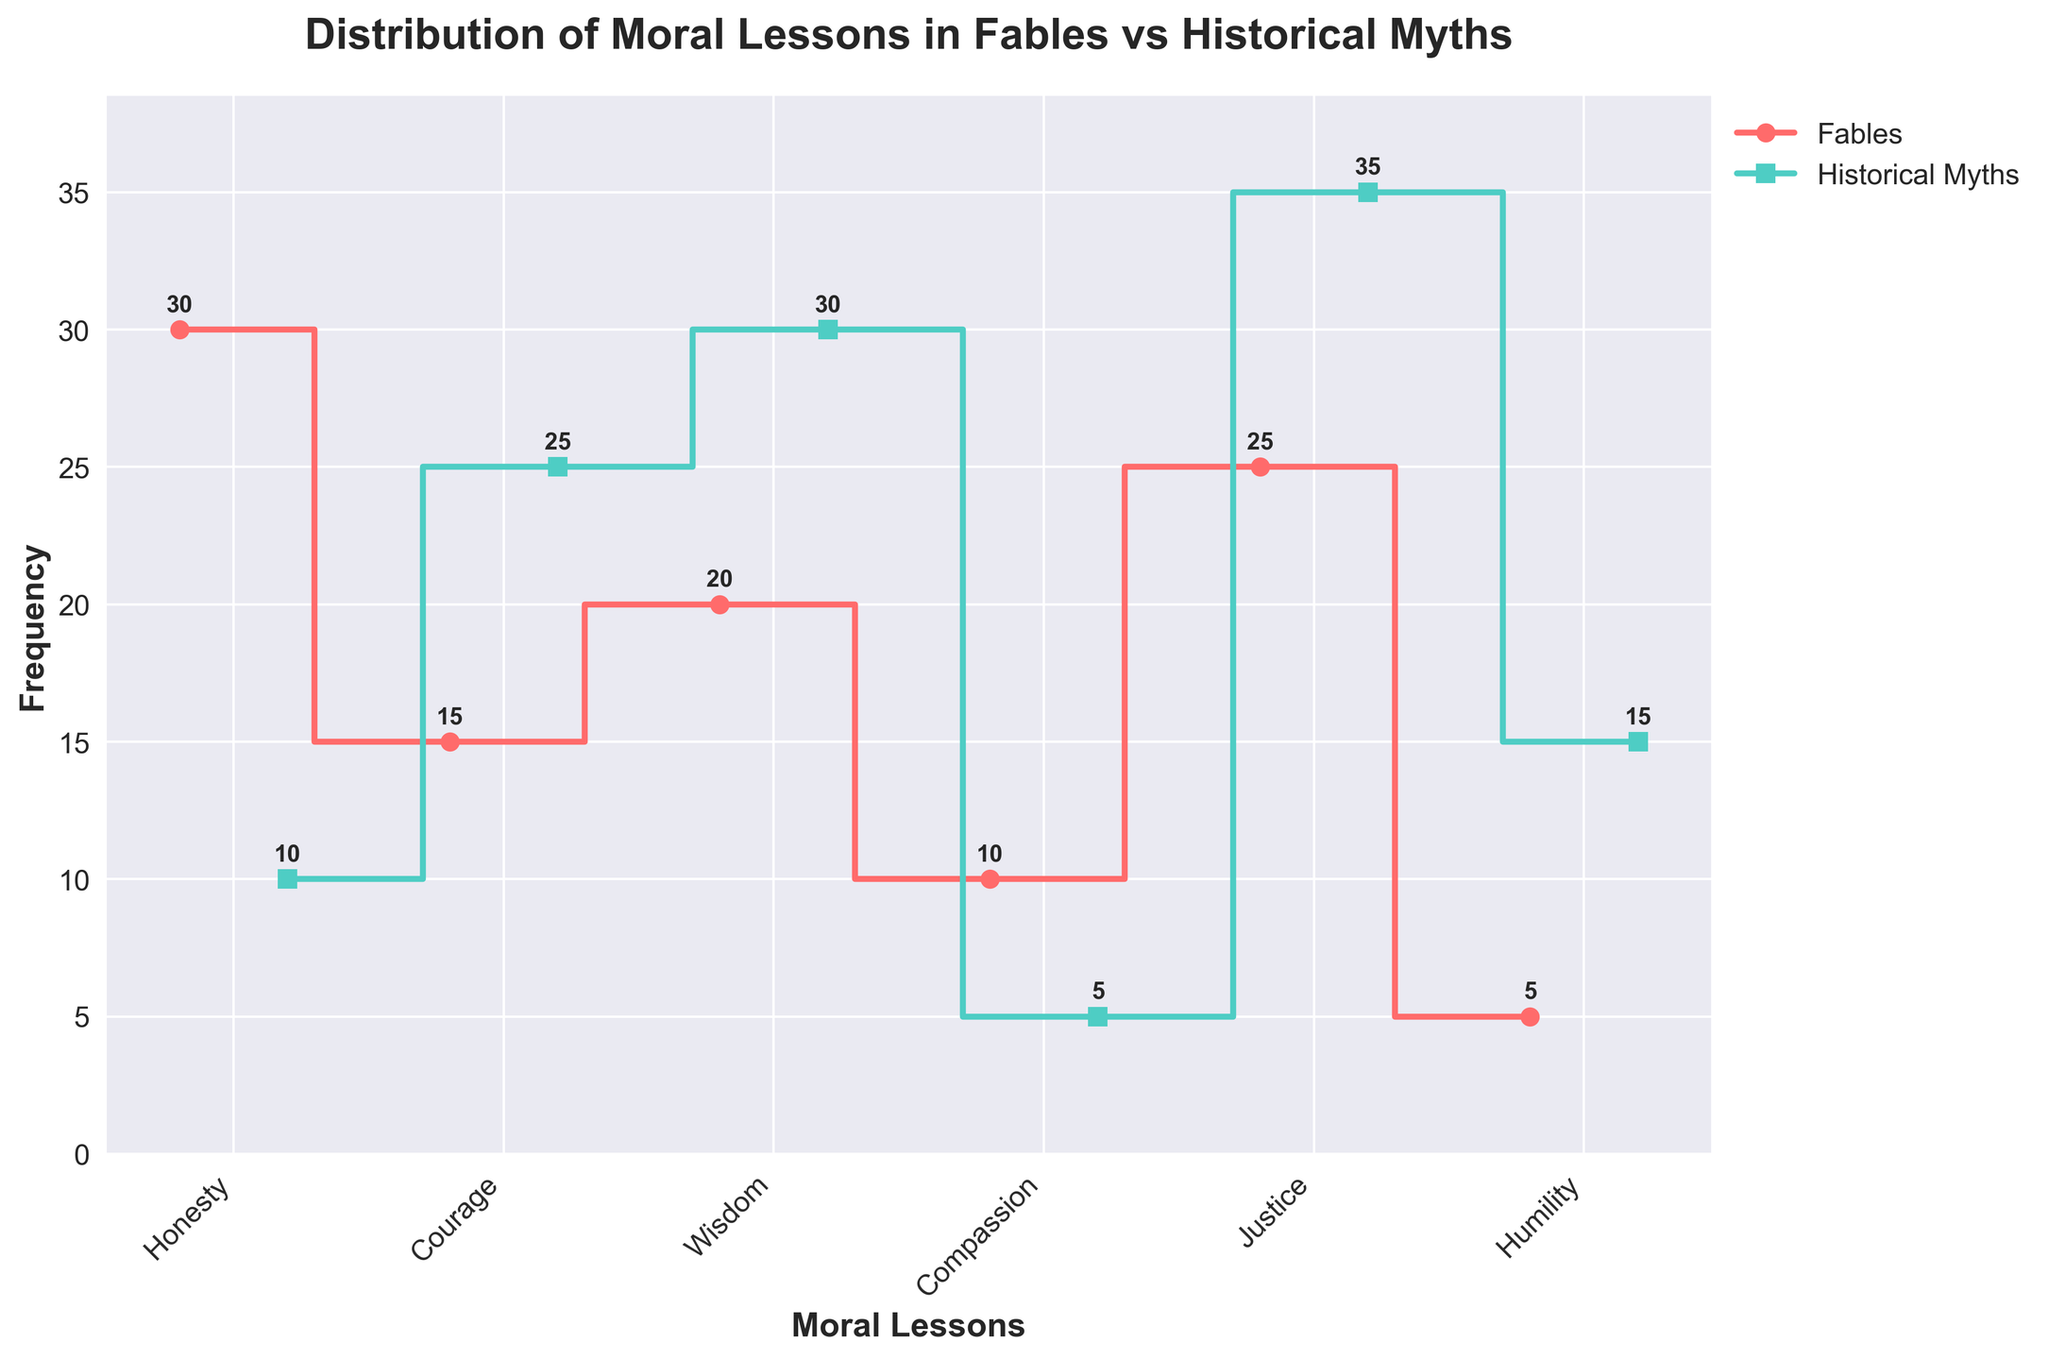What is the total frequency of "Justice" in both Fables and Historical Myths? First, find the frequency of "Justice" in Fables, which is 25. Then, find the frequency of "Justice" in Historical Myths, which is 35. Add these two numbers: 25 + 35 = 60
Answer: 60 Which moral lesson has the fewest occurrences in Fables? Look for the smallest frequency value in the Fables data series. "Humility" has the frequency of 5, which is the smallest.
Answer: Humility Which moral lesson is more emphasized in Historical Myths compared to Fables? Compare the frequencies for each moral lesson between Fables and Historical Myths. "Humility" has a higher frequency in Historical Myths (15) compared to Fables (5).
Answer: Humility What is the difference in frequency of "Honesty" between Fables and Historical Myths? Find the frequency of "Honesty" in Fables (30) and in Historical Myths (10). Subtract the latter from the former: 30 - 10 = 20
Answer: 20 Which moral lessons have higher frequencies in Historical Myths compared to Fables? Compare each moral lesson's frequency in Historical Myths and Fables: 
- Honesty: Fables (30) vs Historical Myths (10) → Fables higher
- Courage: Fables (15) vs Historical Myths (25) → Myths higher
- Wisdom: Fables (20) vs Historical Myths (30) → Myths higher
- Compassion: Fables (10) vs Historical Myths (5) → Fables higher
- Justice: Fables (25) vs Myths (35) → Myths higher
- Humility: Fables (5) vs Historical Myths (15) → Myths higher
Thus, "Courage," "Wisdom," "Justice," and "Humility" have higher frequencies in Historical Myths.
Answer: Courage, Wisdom, Justice, Humility How does the frequency of "Compassion" in Historical Myths compare to in Fables? Look at the frequency of "Compassion" in both categories: 
- Fables: 10
- Historical Myths: 5
Thus, "Compassion" is more frequent in Fables than in Historical Myths.
Answer: More frequent in Fables What is the mean frequency of moral lessons in Historical Myths? Sum up the frequencies in Historical Myths and then divide by the number of moral lessons:
(10 + 25 + 30 + 5 + 35 + 15) / 6 = 120 / 6 = 20
Answer: 20 What is the combined frequency of "Wisdom" and "Courage" in Fables? Find the frequency of "Wisdom" (20) and "Courage" (15) in Fables and add them together: 20 + 15 = 35
Answer: 35 Which moral lesson is represented equally in Fables and Historical Myths? Compare the frequencies of each moral lesson in Fables and Historical Myths. There is no moral lesson with equal frequencies in both categories.
Answer: None What is the overall trend in the frequency distribution between Fables and Historical Myths? Observe the general trend in the bar lengths between Fables and Historical Myths. Most moral lessons have higher frequencies in Historical Myths except for "Honesty" and "Compassion," which are higher in Fables.
Answer: Historical Myths have higher frequencies overall 